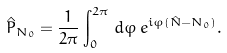<formula> <loc_0><loc_0><loc_500><loc_500>\hat { P } _ { N _ { 0 } } = \frac { 1 } { 2 \pi } \int _ { 0 } ^ { 2 \pi } \, d \varphi \, e ^ { i \varphi ( \hat { N } - N _ { 0 } ) } .</formula> 